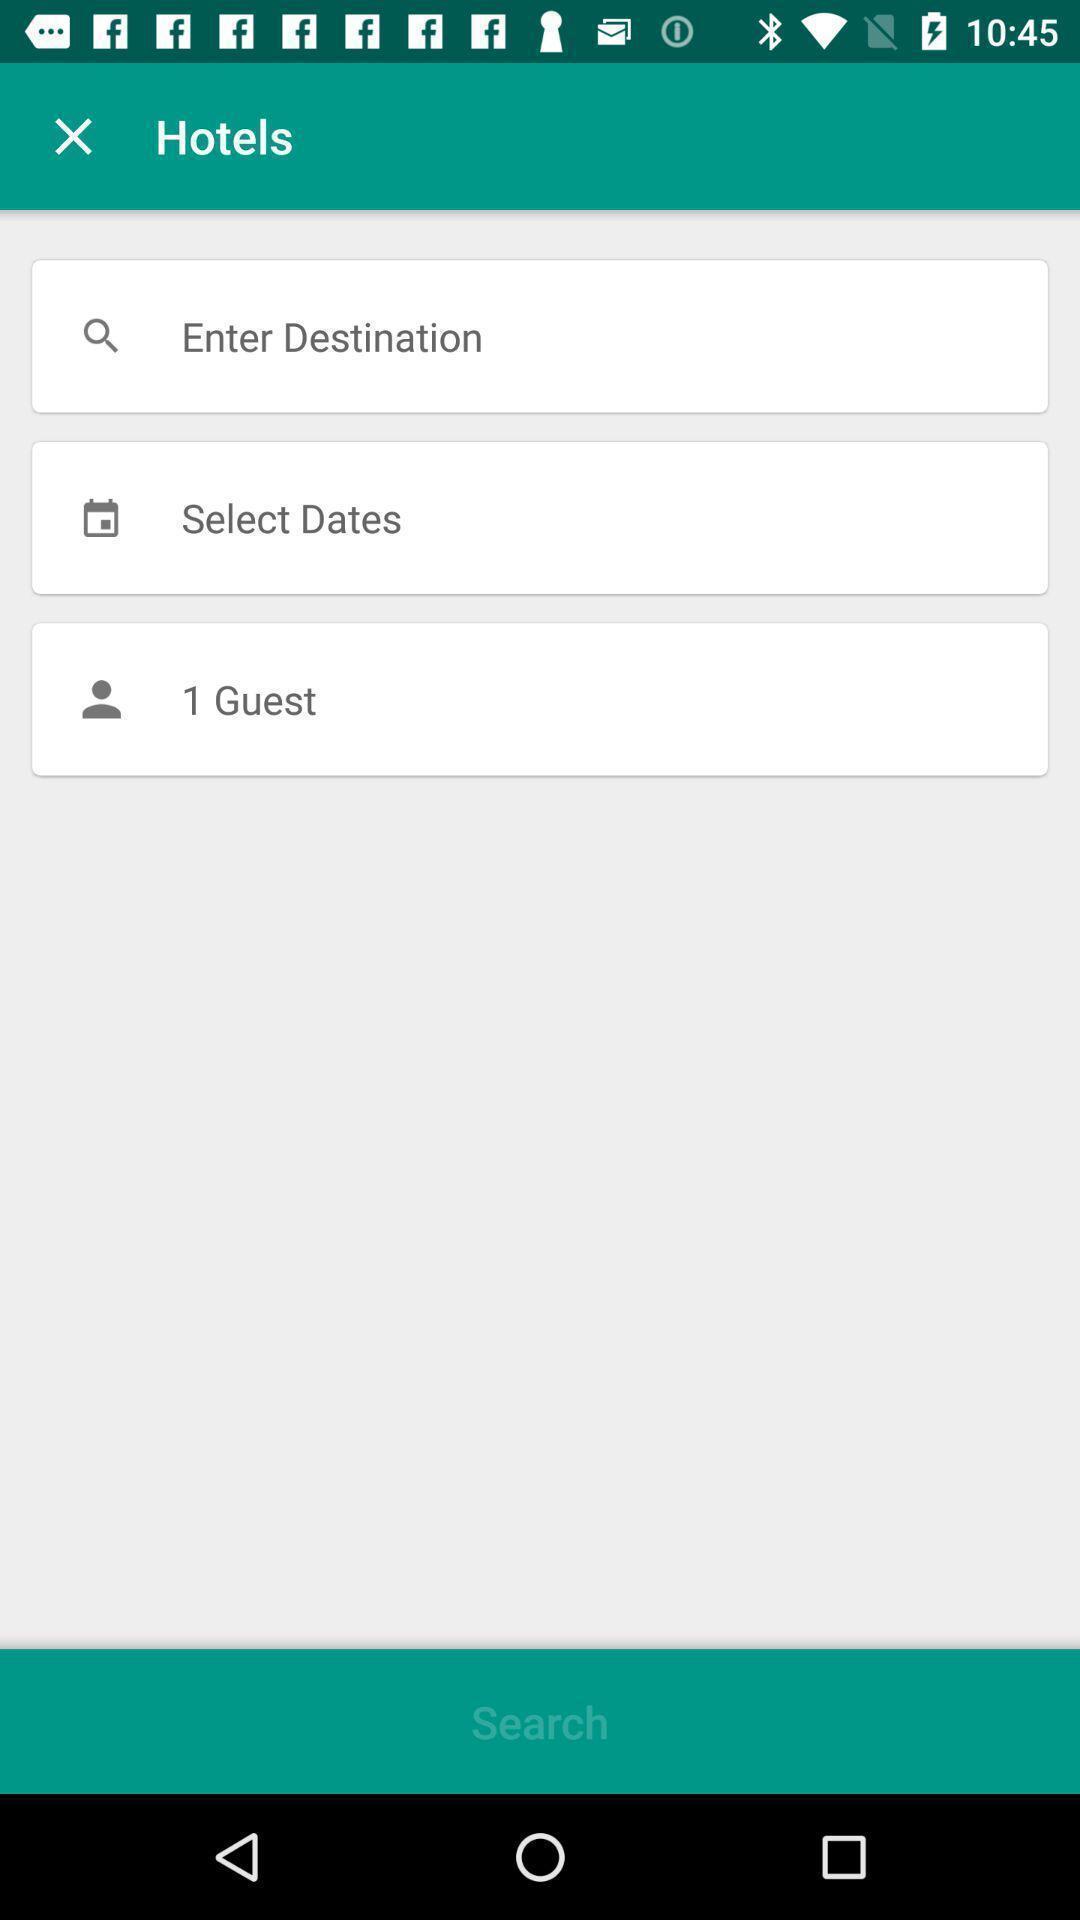Summarize the information in this screenshot. Screen displaying page to enter credentials in a booking app. 